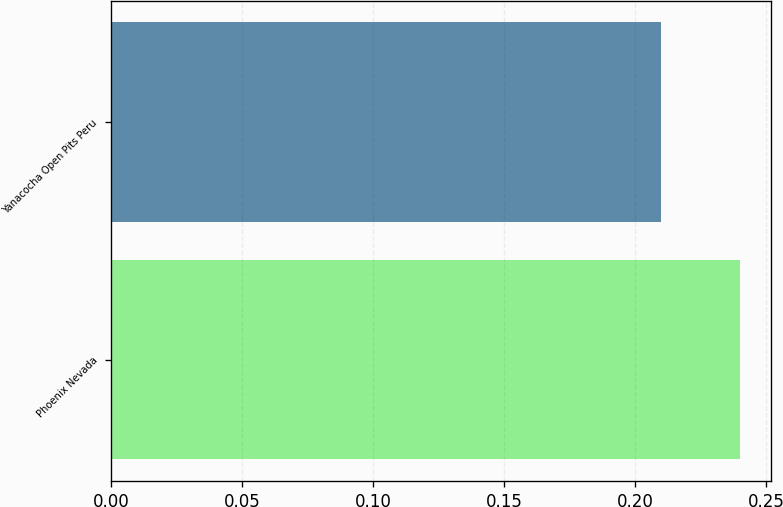Convert chart. <chart><loc_0><loc_0><loc_500><loc_500><bar_chart><fcel>Phoenix Nevada<fcel>Yanacocha Open Pits Peru<nl><fcel>0.24<fcel>0.21<nl></chart> 